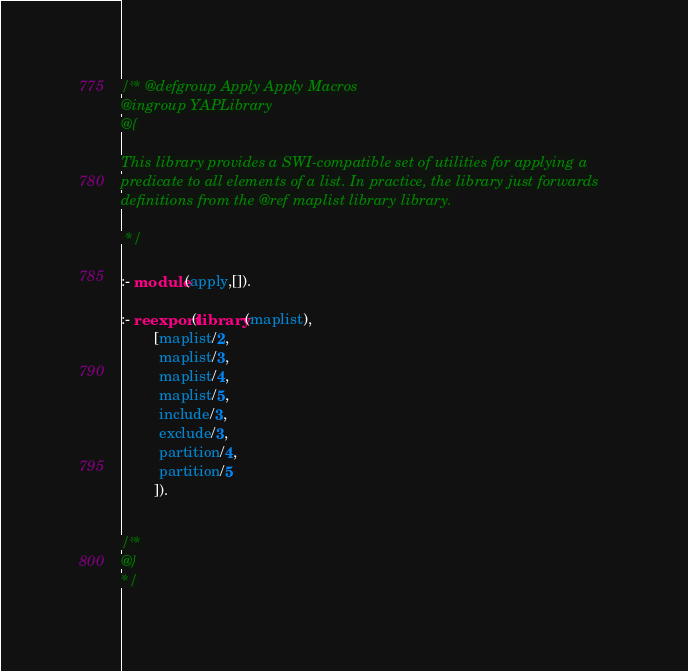<code> <loc_0><loc_0><loc_500><loc_500><_Prolog_>/** @defgroup Apply Apply Macros
@ingroup YAPLibrary
@{

This library provides a SWI-compatible set of utilities for applying a
predicate to all elements of a list. In practice, the library just forwards
definitions from the @ref maplist library library.

 */

:- module(apply,[]).

:- reexport(library(maplist),
	    [maplist/2,
	     maplist/3,
	     maplist/4,
	     maplist/5,
	     include/3,
	     exclude/3,
	     partition/4,
	     partition/5
	    ]).


/**
@}
*/
</code> 